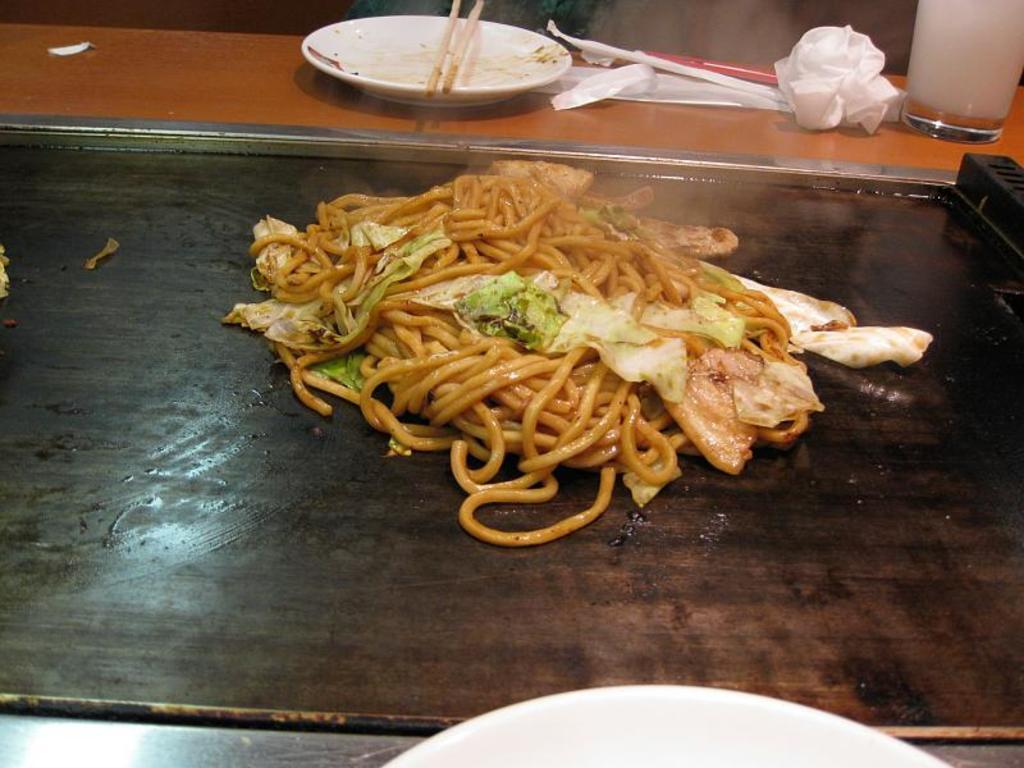What is the main subject in the center of the image? There is a food item in the center of the image. What objects are on the table in the image? There are plates and a glass on the table. What item might be used for cleaning or wiping in the image? Tissues are present on the table for cleaning or wiping. What type of veil can be seen in the image? There is no veil present in the image. Can you describe the field in the image? There is no field present in the image. 